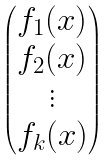Convert formula to latex. <formula><loc_0><loc_0><loc_500><loc_500>\begin{pmatrix} f _ { 1 } ( x ) \\ f _ { 2 } ( x ) \\ \vdots \\ f _ { k } ( x ) \end{pmatrix}</formula> 